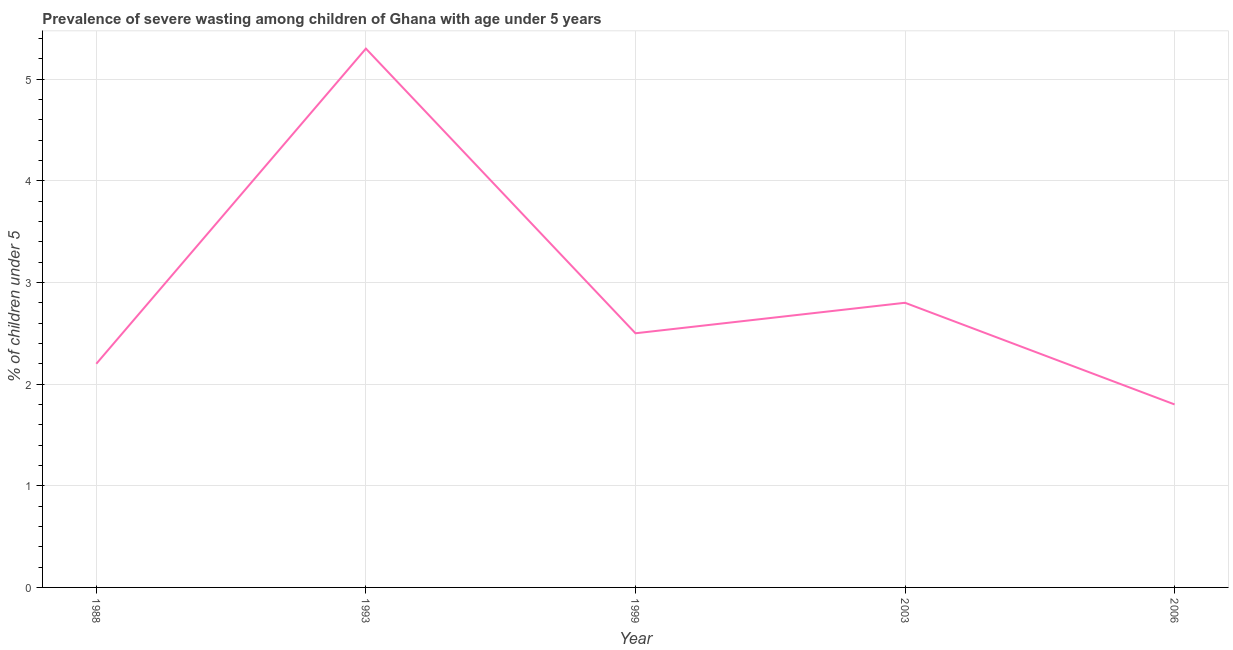What is the prevalence of severe wasting in 2003?
Keep it short and to the point. 2.8. Across all years, what is the maximum prevalence of severe wasting?
Your answer should be compact. 5.3. Across all years, what is the minimum prevalence of severe wasting?
Your response must be concise. 1.8. In which year was the prevalence of severe wasting maximum?
Your response must be concise. 1993. In which year was the prevalence of severe wasting minimum?
Ensure brevity in your answer.  2006. What is the sum of the prevalence of severe wasting?
Your response must be concise. 14.6. What is the difference between the prevalence of severe wasting in 1988 and 1999?
Offer a very short reply. -0.3. What is the average prevalence of severe wasting per year?
Keep it short and to the point. 2.92. What is the median prevalence of severe wasting?
Keep it short and to the point. 2.5. What is the ratio of the prevalence of severe wasting in 1988 to that in 2003?
Offer a very short reply. 0.79. What is the difference between the highest and the second highest prevalence of severe wasting?
Offer a very short reply. 2.5. Is the sum of the prevalence of severe wasting in 1993 and 1999 greater than the maximum prevalence of severe wasting across all years?
Your answer should be compact. Yes. What is the difference between the highest and the lowest prevalence of severe wasting?
Make the answer very short. 3.5. How many years are there in the graph?
Your answer should be very brief. 5. What is the difference between two consecutive major ticks on the Y-axis?
Offer a very short reply. 1. Are the values on the major ticks of Y-axis written in scientific E-notation?
Keep it short and to the point. No. What is the title of the graph?
Keep it short and to the point. Prevalence of severe wasting among children of Ghana with age under 5 years. What is the label or title of the X-axis?
Your answer should be very brief. Year. What is the label or title of the Y-axis?
Offer a very short reply.  % of children under 5. What is the  % of children under 5 of 1988?
Provide a short and direct response. 2.2. What is the  % of children under 5 in 1993?
Offer a very short reply. 5.3. What is the  % of children under 5 in 1999?
Your answer should be very brief. 2.5. What is the  % of children under 5 of 2003?
Your answer should be very brief. 2.8. What is the  % of children under 5 in 2006?
Your answer should be compact. 1.8. What is the difference between the  % of children under 5 in 1988 and 2006?
Offer a very short reply. 0.4. What is the difference between the  % of children under 5 in 1993 and 1999?
Provide a short and direct response. 2.8. What is the difference between the  % of children under 5 in 1993 and 2003?
Provide a succinct answer. 2.5. What is the difference between the  % of children under 5 in 1993 and 2006?
Keep it short and to the point. 3.5. What is the difference between the  % of children under 5 in 2003 and 2006?
Your response must be concise. 1. What is the ratio of the  % of children under 5 in 1988 to that in 1993?
Offer a terse response. 0.41. What is the ratio of the  % of children under 5 in 1988 to that in 1999?
Ensure brevity in your answer.  0.88. What is the ratio of the  % of children under 5 in 1988 to that in 2003?
Provide a succinct answer. 0.79. What is the ratio of the  % of children under 5 in 1988 to that in 2006?
Provide a succinct answer. 1.22. What is the ratio of the  % of children under 5 in 1993 to that in 1999?
Your answer should be very brief. 2.12. What is the ratio of the  % of children under 5 in 1993 to that in 2003?
Your response must be concise. 1.89. What is the ratio of the  % of children under 5 in 1993 to that in 2006?
Make the answer very short. 2.94. What is the ratio of the  % of children under 5 in 1999 to that in 2003?
Offer a very short reply. 0.89. What is the ratio of the  % of children under 5 in 1999 to that in 2006?
Your answer should be very brief. 1.39. What is the ratio of the  % of children under 5 in 2003 to that in 2006?
Make the answer very short. 1.56. 